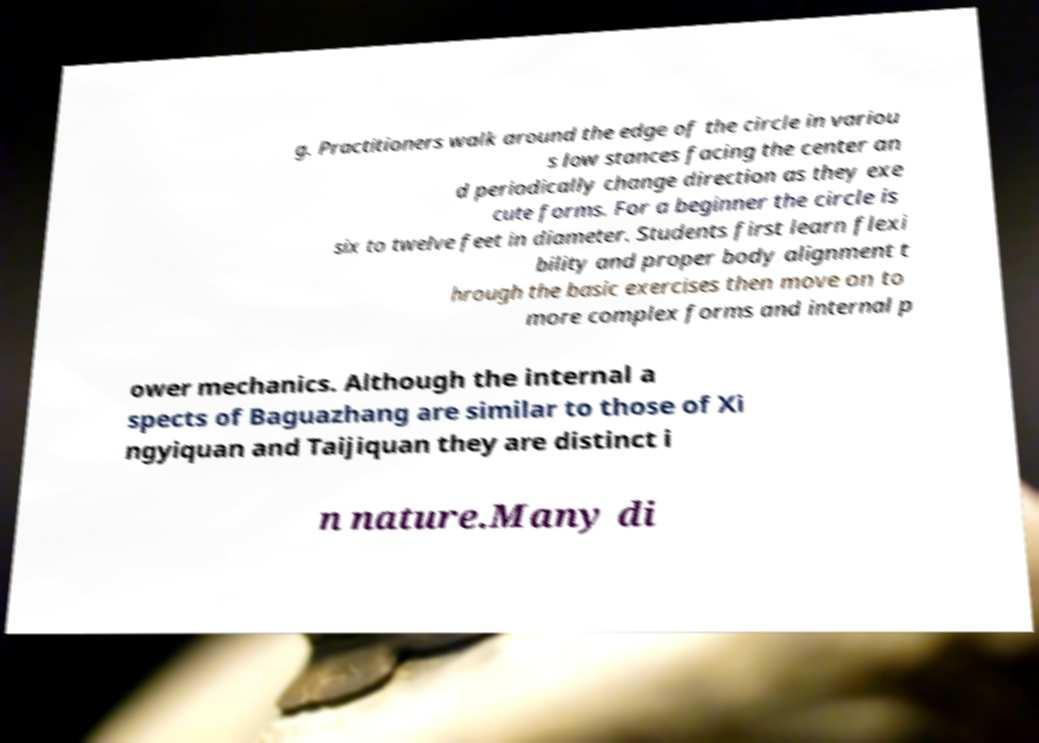What messages or text are displayed in this image? I need them in a readable, typed format. g. Practitioners walk around the edge of the circle in variou s low stances facing the center an d periodically change direction as they exe cute forms. For a beginner the circle is six to twelve feet in diameter. Students first learn flexi bility and proper body alignment t hrough the basic exercises then move on to more complex forms and internal p ower mechanics. Although the internal a spects of Baguazhang are similar to those of Xi ngyiquan and Taijiquan they are distinct i n nature.Many di 